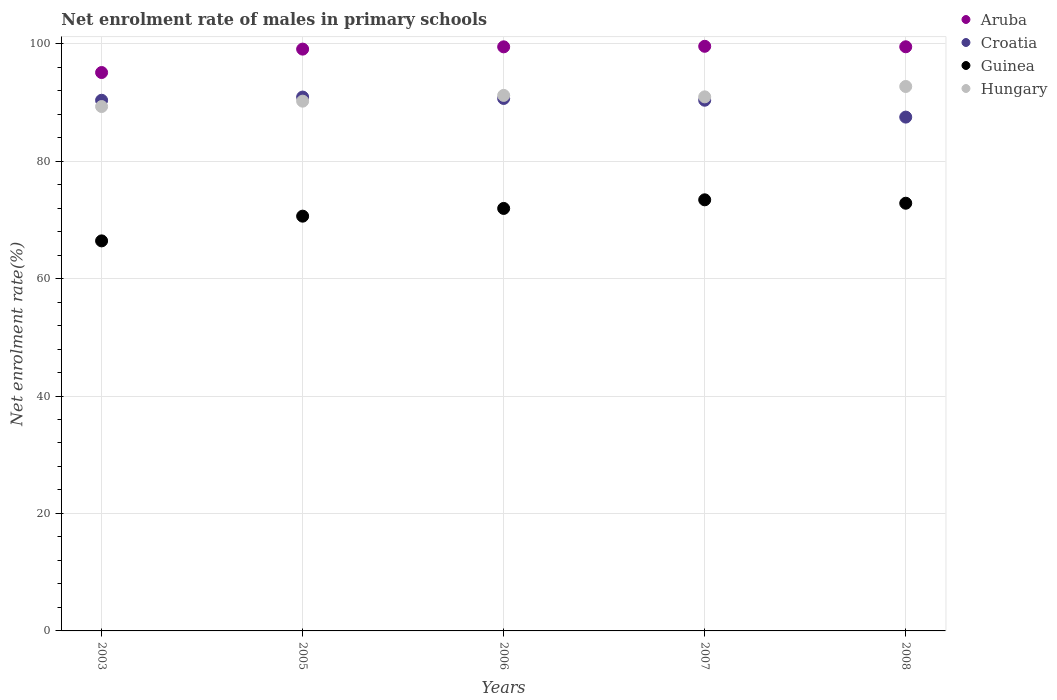Is the number of dotlines equal to the number of legend labels?
Keep it short and to the point. Yes. What is the net enrolment rate of males in primary schools in Hungary in 2008?
Ensure brevity in your answer.  92.7. Across all years, what is the maximum net enrolment rate of males in primary schools in Aruba?
Offer a very short reply. 99.55. Across all years, what is the minimum net enrolment rate of males in primary schools in Croatia?
Offer a terse response. 87.49. In which year was the net enrolment rate of males in primary schools in Guinea minimum?
Provide a succinct answer. 2003. What is the total net enrolment rate of males in primary schools in Aruba in the graph?
Make the answer very short. 492.61. What is the difference between the net enrolment rate of males in primary schools in Croatia in 2003 and that in 2005?
Provide a short and direct response. -0.55. What is the difference between the net enrolment rate of males in primary schools in Croatia in 2006 and the net enrolment rate of males in primary schools in Guinea in 2003?
Make the answer very short. 24.25. What is the average net enrolment rate of males in primary schools in Croatia per year?
Offer a terse response. 89.96. In the year 2007, what is the difference between the net enrolment rate of males in primary schools in Hungary and net enrolment rate of males in primary schools in Croatia?
Keep it short and to the point. 0.58. In how many years, is the net enrolment rate of males in primary schools in Guinea greater than 4 %?
Provide a short and direct response. 5. What is the ratio of the net enrolment rate of males in primary schools in Guinea in 2003 to that in 2006?
Make the answer very short. 0.92. Is the net enrolment rate of males in primary schools in Aruba in 2007 less than that in 2008?
Your answer should be very brief. No. What is the difference between the highest and the second highest net enrolment rate of males in primary schools in Hungary?
Your answer should be very brief. 1.52. What is the difference between the highest and the lowest net enrolment rate of males in primary schools in Guinea?
Make the answer very short. 6.99. Is the sum of the net enrolment rate of males in primary schools in Guinea in 2003 and 2007 greater than the maximum net enrolment rate of males in primary schools in Aruba across all years?
Your answer should be very brief. Yes. Is it the case that in every year, the sum of the net enrolment rate of males in primary schools in Hungary and net enrolment rate of males in primary schools in Aruba  is greater than the sum of net enrolment rate of males in primary schools in Croatia and net enrolment rate of males in primary schools in Guinea?
Give a very brief answer. Yes. Is it the case that in every year, the sum of the net enrolment rate of males in primary schools in Croatia and net enrolment rate of males in primary schools in Aruba  is greater than the net enrolment rate of males in primary schools in Guinea?
Make the answer very short. Yes. Does the net enrolment rate of males in primary schools in Hungary monotonically increase over the years?
Give a very brief answer. No. Is the net enrolment rate of males in primary schools in Croatia strictly greater than the net enrolment rate of males in primary schools in Aruba over the years?
Your answer should be very brief. No. Is the net enrolment rate of males in primary schools in Guinea strictly less than the net enrolment rate of males in primary schools in Croatia over the years?
Offer a terse response. Yes. How many years are there in the graph?
Offer a very short reply. 5. What is the difference between two consecutive major ticks on the Y-axis?
Provide a succinct answer. 20. Are the values on the major ticks of Y-axis written in scientific E-notation?
Make the answer very short. No. Does the graph contain any zero values?
Your response must be concise. No. Does the graph contain grids?
Your response must be concise. Yes. Where does the legend appear in the graph?
Keep it short and to the point. Top right. How are the legend labels stacked?
Ensure brevity in your answer.  Vertical. What is the title of the graph?
Give a very brief answer. Net enrolment rate of males in primary schools. What is the label or title of the X-axis?
Ensure brevity in your answer.  Years. What is the label or title of the Y-axis?
Keep it short and to the point. Net enrolment rate(%). What is the Net enrolment rate(%) of Aruba in 2003?
Your answer should be compact. 95.08. What is the Net enrolment rate(%) in Croatia in 2003?
Your response must be concise. 90.36. What is the Net enrolment rate(%) of Guinea in 2003?
Give a very brief answer. 66.42. What is the Net enrolment rate(%) in Hungary in 2003?
Your response must be concise. 89.29. What is the Net enrolment rate(%) in Aruba in 2005?
Keep it short and to the point. 99.07. What is the Net enrolment rate(%) of Croatia in 2005?
Give a very brief answer. 90.9. What is the Net enrolment rate(%) of Guinea in 2005?
Your answer should be compact. 70.62. What is the Net enrolment rate(%) of Hungary in 2005?
Offer a terse response. 90.21. What is the Net enrolment rate(%) of Aruba in 2006?
Keep it short and to the point. 99.46. What is the Net enrolment rate(%) in Croatia in 2006?
Make the answer very short. 90.67. What is the Net enrolment rate(%) in Guinea in 2006?
Keep it short and to the point. 71.94. What is the Net enrolment rate(%) in Hungary in 2006?
Offer a very short reply. 91.19. What is the Net enrolment rate(%) of Aruba in 2007?
Your answer should be very brief. 99.55. What is the Net enrolment rate(%) in Croatia in 2007?
Ensure brevity in your answer.  90.36. What is the Net enrolment rate(%) in Guinea in 2007?
Make the answer very short. 73.41. What is the Net enrolment rate(%) of Hungary in 2007?
Offer a very short reply. 90.94. What is the Net enrolment rate(%) of Aruba in 2008?
Offer a very short reply. 99.46. What is the Net enrolment rate(%) in Croatia in 2008?
Your answer should be compact. 87.49. What is the Net enrolment rate(%) in Guinea in 2008?
Offer a very short reply. 72.83. What is the Net enrolment rate(%) of Hungary in 2008?
Ensure brevity in your answer.  92.7. Across all years, what is the maximum Net enrolment rate(%) of Aruba?
Your answer should be compact. 99.55. Across all years, what is the maximum Net enrolment rate(%) in Croatia?
Provide a succinct answer. 90.9. Across all years, what is the maximum Net enrolment rate(%) in Guinea?
Provide a short and direct response. 73.41. Across all years, what is the maximum Net enrolment rate(%) in Hungary?
Provide a short and direct response. 92.7. Across all years, what is the minimum Net enrolment rate(%) of Aruba?
Offer a terse response. 95.08. Across all years, what is the minimum Net enrolment rate(%) of Croatia?
Provide a succinct answer. 87.49. Across all years, what is the minimum Net enrolment rate(%) of Guinea?
Offer a terse response. 66.42. Across all years, what is the minimum Net enrolment rate(%) of Hungary?
Provide a succinct answer. 89.29. What is the total Net enrolment rate(%) in Aruba in the graph?
Your answer should be very brief. 492.61. What is the total Net enrolment rate(%) in Croatia in the graph?
Your answer should be compact. 449.78. What is the total Net enrolment rate(%) of Guinea in the graph?
Offer a very short reply. 355.21. What is the total Net enrolment rate(%) in Hungary in the graph?
Your answer should be very brief. 454.32. What is the difference between the Net enrolment rate(%) of Aruba in 2003 and that in 2005?
Your answer should be compact. -3.99. What is the difference between the Net enrolment rate(%) of Croatia in 2003 and that in 2005?
Provide a succinct answer. -0.55. What is the difference between the Net enrolment rate(%) of Guinea in 2003 and that in 2005?
Offer a very short reply. -4.21. What is the difference between the Net enrolment rate(%) in Hungary in 2003 and that in 2005?
Provide a succinct answer. -0.92. What is the difference between the Net enrolment rate(%) in Aruba in 2003 and that in 2006?
Give a very brief answer. -4.37. What is the difference between the Net enrolment rate(%) in Croatia in 2003 and that in 2006?
Make the answer very short. -0.31. What is the difference between the Net enrolment rate(%) of Guinea in 2003 and that in 2006?
Offer a very short reply. -5.52. What is the difference between the Net enrolment rate(%) of Hungary in 2003 and that in 2006?
Your answer should be very brief. -1.9. What is the difference between the Net enrolment rate(%) of Aruba in 2003 and that in 2007?
Give a very brief answer. -4.46. What is the difference between the Net enrolment rate(%) of Croatia in 2003 and that in 2007?
Offer a very short reply. -0.01. What is the difference between the Net enrolment rate(%) in Guinea in 2003 and that in 2007?
Provide a succinct answer. -6.99. What is the difference between the Net enrolment rate(%) in Hungary in 2003 and that in 2007?
Offer a terse response. -1.65. What is the difference between the Net enrolment rate(%) of Aruba in 2003 and that in 2008?
Provide a short and direct response. -4.38. What is the difference between the Net enrolment rate(%) of Croatia in 2003 and that in 2008?
Offer a terse response. 2.87. What is the difference between the Net enrolment rate(%) in Guinea in 2003 and that in 2008?
Ensure brevity in your answer.  -6.41. What is the difference between the Net enrolment rate(%) in Hungary in 2003 and that in 2008?
Your answer should be very brief. -3.41. What is the difference between the Net enrolment rate(%) in Aruba in 2005 and that in 2006?
Provide a succinct answer. -0.39. What is the difference between the Net enrolment rate(%) in Croatia in 2005 and that in 2006?
Your answer should be compact. 0.24. What is the difference between the Net enrolment rate(%) in Guinea in 2005 and that in 2006?
Keep it short and to the point. -1.32. What is the difference between the Net enrolment rate(%) in Hungary in 2005 and that in 2006?
Provide a short and direct response. -0.98. What is the difference between the Net enrolment rate(%) of Aruba in 2005 and that in 2007?
Keep it short and to the point. -0.48. What is the difference between the Net enrolment rate(%) in Croatia in 2005 and that in 2007?
Provide a short and direct response. 0.54. What is the difference between the Net enrolment rate(%) of Guinea in 2005 and that in 2007?
Offer a terse response. -2.78. What is the difference between the Net enrolment rate(%) of Hungary in 2005 and that in 2007?
Ensure brevity in your answer.  -0.73. What is the difference between the Net enrolment rate(%) in Aruba in 2005 and that in 2008?
Provide a succinct answer. -0.4. What is the difference between the Net enrolment rate(%) of Croatia in 2005 and that in 2008?
Your answer should be compact. 3.41. What is the difference between the Net enrolment rate(%) of Guinea in 2005 and that in 2008?
Offer a very short reply. -2.2. What is the difference between the Net enrolment rate(%) in Hungary in 2005 and that in 2008?
Offer a very short reply. -2.5. What is the difference between the Net enrolment rate(%) in Aruba in 2006 and that in 2007?
Your answer should be compact. -0.09. What is the difference between the Net enrolment rate(%) in Croatia in 2006 and that in 2007?
Your response must be concise. 0.3. What is the difference between the Net enrolment rate(%) in Guinea in 2006 and that in 2007?
Provide a short and direct response. -1.47. What is the difference between the Net enrolment rate(%) of Hungary in 2006 and that in 2007?
Make the answer very short. 0.25. What is the difference between the Net enrolment rate(%) of Aruba in 2006 and that in 2008?
Make the answer very short. -0.01. What is the difference between the Net enrolment rate(%) in Croatia in 2006 and that in 2008?
Offer a very short reply. 3.18. What is the difference between the Net enrolment rate(%) of Guinea in 2006 and that in 2008?
Provide a short and direct response. -0.89. What is the difference between the Net enrolment rate(%) in Hungary in 2006 and that in 2008?
Your answer should be compact. -1.52. What is the difference between the Net enrolment rate(%) of Aruba in 2007 and that in 2008?
Provide a succinct answer. 0.08. What is the difference between the Net enrolment rate(%) in Croatia in 2007 and that in 2008?
Keep it short and to the point. 2.87. What is the difference between the Net enrolment rate(%) in Guinea in 2007 and that in 2008?
Your response must be concise. 0.58. What is the difference between the Net enrolment rate(%) in Hungary in 2007 and that in 2008?
Keep it short and to the point. -1.76. What is the difference between the Net enrolment rate(%) in Aruba in 2003 and the Net enrolment rate(%) in Croatia in 2005?
Keep it short and to the point. 4.18. What is the difference between the Net enrolment rate(%) of Aruba in 2003 and the Net enrolment rate(%) of Guinea in 2005?
Offer a very short reply. 24.46. What is the difference between the Net enrolment rate(%) of Aruba in 2003 and the Net enrolment rate(%) of Hungary in 2005?
Make the answer very short. 4.88. What is the difference between the Net enrolment rate(%) of Croatia in 2003 and the Net enrolment rate(%) of Guinea in 2005?
Give a very brief answer. 19.73. What is the difference between the Net enrolment rate(%) of Croatia in 2003 and the Net enrolment rate(%) of Hungary in 2005?
Offer a terse response. 0.15. What is the difference between the Net enrolment rate(%) in Guinea in 2003 and the Net enrolment rate(%) in Hungary in 2005?
Offer a terse response. -23.79. What is the difference between the Net enrolment rate(%) in Aruba in 2003 and the Net enrolment rate(%) in Croatia in 2006?
Offer a very short reply. 4.42. What is the difference between the Net enrolment rate(%) in Aruba in 2003 and the Net enrolment rate(%) in Guinea in 2006?
Provide a succinct answer. 23.14. What is the difference between the Net enrolment rate(%) in Aruba in 2003 and the Net enrolment rate(%) in Hungary in 2006?
Ensure brevity in your answer.  3.9. What is the difference between the Net enrolment rate(%) in Croatia in 2003 and the Net enrolment rate(%) in Guinea in 2006?
Make the answer very short. 18.42. What is the difference between the Net enrolment rate(%) in Croatia in 2003 and the Net enrolment rate(%) in Hungary in 2006?
Offer a terse response. -0.83. What is the difference between the Net enrolment rate(%) of Guinea in 2003 and the Net enrolment rate(%) of Hungary in 2006?
Offer a terse response. -24.77. What is the difference between the Net enrolment rate(%) of Aruba in 2003 and the Net enrolment rate(%) of Croatia in 2007?
Your answer should be very brief. 4.72. What is the difference between the Net enrolment rate(%) in Aruba in 2003 and the Net enrolment rate(%) in Guinea in 2007?
Your answer should be very brief. 21.68. What is the difference between the Net enrolment rate(%) of Aruba in 2003 and the Net enrolment rate(%) of Hungary in 2007?
Provide a short and direct response. 4.14. What is the difference between the Net enrolment rate(%) of Croatia in 2003 and the Net enrolment rate(%) of Guinea in 2007?
Keep it short and to the point. 16.95. What is the difference between the Net enrolment rate(%) in Croatia in 2003 and the Net enrolment rate(%) in Hungary in 2007?
Offer a very short reply. -0.58. What is the difference between the Net enrolment rate(%) of Guinea in 2003 and the Net enrolment rate(%) of Hungary in 2007?
Your response must be concise. -24.52. What is the difference between the Net enrolment rate(%) of Aruba in 2003 and the Net enrolment rate(%) of Croatia in 2008?
Your answer should be compact. 7.59. What is the difference between the Net enrolment rate(%) of Aruba in 2003 and the Net enrolment rate(%) of Guinea in 2008?
Make the answer very short. 22.26. What is the difference between the Net enrolment rate(%) of Aruba in 2003 and the Net enrolment rate(%) of Hungary in 2008?
Your response must be concise. 2.38. What is the difference between the Net enrolment rate(%) of Croatia in 2003 and the Net enrolment rate(%) of Guinea in 2008?
Offer a terse response. 17.53. What is the difference between the Net enrolment rate(%) of Croatia in 2003 and the Net enrolment rate(%) of Hungary in 2008?
Provide a succinct answer. -2.35. What is the difference between the Net enrolment rate(%) in Guinea in 2003 and the Net enrolment rate(%) in Hungary in 2008?
Your response must be concise. -26.29. What is the difference between the Net enrolment rate(%) of Aruba in 2005 and the Net enrolment rate(%) of Croatia in 2006?
Make the answer very short. 8.4. What is the difference between the Net enrolment rate(%) of Aruba in 2005 and the Net enrolment rate(%) of Guinea in 2006?
Provide a short and direct response. 27.13. What is the difference between the Net enrolment rate(%) in Aruba in 2005 and the Net enrolment rate(%) in Hungary in 2006?
Provide a short and direct response. 7.88. What is the difference between the Net enrolment rate(%) of Croatia in 2005 and the Net enrolment rate(%) of Guinea in 2006?
Keep it short and to the point. 18.96. What is the difference between the Net enrolment rate(%) in Croatia in 2005 and the Net enrolment rate(%) in Hungary in 2006?
Make the answer very short. -0.28. What is the difference between the Net enrolment rate(%) of Guinea in 2005 and the Net enrolment rate(%) of Hungary in 2006?
Keep it short and to the point. -20.56. What is the difference between the Net enrolment rate(%) of Aruba in 2005 and the Net enrolment rate(%) of Croatia in 2007?
Make the answer very short. 8.7. What is the difference between the Net enrolment rate(%) in Aruba in 2005 and the Net enrolment rate(%) in Guinea in 2007?
Make the answer very short. 25.66. What is the difference between the Net enrolment rate(%) in Aruba in 2005 and the Net enrolment rate(%) in Hungary in 2007?
Give a very brief answer. 8.13. What is the difference between the Net enrolment rate(%) in Croatia in 2005 and the Net enrolment rate(%) in Guinea in 2007?
Offer a very short reply. 17.5. What is the difference between the Net enrolment rate(%) of Croatia in 2005 and the Net enrolment rate(%) of Hungary in 2007?
Your response must be concise. -0.04. What is the difference between the Net enrolment rate(%) of Guinea in 2005 and the Net enrolment rate(%) of Hungary in 2007?
Your response must be concise. -20.32. What is the difference between the Net enrolment rate(%) of Aruba in 2005 and the Net enrolment rate(%) of Croatia in 2008?
Your response must be concise. 11.58. What is the difference between the Net enrolment rate(%) of Aruba in 2005 and the Net enrolment rate(%) of Guinea in 2008?
Your response must be concise. 26.24. What is the difference between the Net enrolment rate(%) of Aruba in 2005 and the Net enrolment rate(%) of Hungary in 2008?
Provide a short and direct response. 6.36. What is the difference between the Net enrolment rate(%) of Croatia in 2005 and the Net enrolment rate(%) of Guinea in 2008?
Provide a succinct answer. 18.08. What is the difference between the Net enrolment rate(%) in Croatia in 2005 and the Net enrolment rate(%) in Hungary in 2008?
Provide a short and direct response. -1.8. What is the difference between the Net enrolment rate(%) of Guinea in 2005 and the Net enrolment rate(%) of Hungary in 2008?
Your response must be concise. -22.08. What is the difference between the Net enrolment rate(%) of Aruba in 2006 and the Net enrolment rate(%) of Croatia in 2007?
Your response must be concise. 9.09. What is the difference between the Net enrolment rate(%) of Aruba in 2006 and the Net enrolment rate(%) of Guinea in 2007?
Ensure brevity in your answer.  26.05. What is the difference between the Net enrolment rate(%) in Aruba in 2006 and the Net enrolment rate(%) in Hungary in 2007?
Provide a short and direct response. 8.52. What is the difference between the Net enrolment rate(%) of Croatia in 2006 and the Net enrolment rate(%) of Guinea in 2007?
Make the answer very short. 17.26. What is the difference between the Net enrolment rate(%) in Croatia in 2006 and the Net enrolment rate(%) in Hungary in 2007?
Your response must be concise. -0.27. What is the difference between the Net enrolment rate(%) of Guinea in 2006 and the Net enrolment rate(%) of Hungary in 2007?
Provide a succinct answer. -19. What is the difference between the Net enrolment rate(%) in Aruba in 2006 and the Net enrolment rate(%) in Croatia in 2008?
Offer a very short reply. 11.97. What is the difference between the Net enrolment rate(%) of Aruba in 2006 and the Net enrolment rate(%) of Guinea in 2008?
Offer a very short reply. 26.63. What is the difference between the Net enrolment rate(%) of Aruba in 2006 and the Net enrolment rate(%) of Hungary in 2008?
Provide a succinct answer. 6.75. What is the difference between the Net enrolment rate(%) in Croatia in 2006 and the Net enrolment rate(%) in Guinea in 2008?
Provide a succinct answer. 17.84. What is the difference between the Net enrolment rate(%) in Croatia in 2006 and the Net enrolment rate(%) in Hungary in 2008?
Give a very brief answer. -2.04. What is the difference between the Net enrolment rate(%) in Guinea in 2006 and the Net enrolment rate(%) in Hungary in 2008?
Make the answer very short. -20.76. What is the difference between the Net enrolment rate(%) of Aruba in 2007 and the Net enrolment rate(%) of Croatia in 2008?
Make the answer very short. 12.06. What is the difference between the Net enrolment rate(%) of Aruba in 2007 and the Net enrolment rate(%) of Guinea in 2008?
Give a very brief answer. 26.72. What is the difference between the Net enrolment rate(%) in Aruba in 2007 and the Net enrolment rate(%) in Hungary in 2008?
Make the answer very short. 6.84. What is the difference between the Net enrolment rate(%) in Croatia in 2007 and the Net enrolment rate(%) in Guinea in 2008?
Make the answer very short. 17.54. What is the difference between the Net enrolment rate(%) of Croatia in 2007 and the Net enrolment rate(%) of Hungary in 2008?
Your answer should be compact. -2.34. What is the difference between the Net enrolment rate(%) in Guinea in 2007 and the Net enrolment rate(%) in Hungary in 2008?
Give a very brief answer. -19.3. What is the average Net enrolment rate(%) in Aruba per year?
Provide a short and direct response. 98.52. What is the average Net enrolment rate(%) of Croatia per year?
Your answer should be very brief. 89.96. What is the average Net enrolment rate(%) in Guinea per year?
Give a very brief answer. 71.04. What is the average Net enrolment rate(%) in Hungary per year?
Provide a short and direct response. 90.86. In the year 2003, what is the difference between the Net enrolment rate(%) in Aruba and Net enrolment rate(%) in Croatia?
Make the answer very short. 4.73. In the year 2003, what is the difference between the Net enrolment rate(%) in Aruba and Net enrolment rate(%) in Guinea?
Provide a short and direct response. 28.67. In the year 2003, what is the difference between the Net enrolment rate(%) in Aruba and Net enrolment rate(%) in Hungary?
Keep it short and to the point. 5.79. In the year 2003, what is the difference between the Net enrolment rate(%) in Croatia and Net enrolment rate(%) in Guinea?
Offer a terse response. 23.94. In the year 2003, what is the difference between the Net enrolment rate(%) of Croatia and Net enrolment rate(%) of Hungary?
Ensure brevity in your answer.  1.07. In the year 2003, what is the difference between the Net enrolment rate(%) of Guinea and Net enrolment rate(%) of Hungary?
Ensure brevity in your answer.  -22.88. In the year 2005, what is the difference between the Net enrolment rate(%) in Aruba and Net enrolment rate(%) in Croatia?
Offer a very short reply. 8.16. In the year 2005, what is the difference between the Net enrolment rate(%) of Aruba and Net enrolment rate(%) of Guinea?
Make the answer very short. 28.44. In the year 2005, what is the difference between the Net enrolment rate(%) of Aruba and Net enrolment rate(%) of Hungary?
Provide a succinct answer. 8.86. In the year 2005, what is the difference between the Net enrolment rate(%) in Croatia and Net enrolment rate(%) in Guinea?
Provide a short and direct response. 20.28. In the year 2005, what is the difference between the Net enrolment rate(%) in Croatia and Net enrolment rate(%) in Hungary?
Offer a terse response. 0.7. In the year 2005, what is the difference between the Net enrolment rate(%) in Guinea and Net enrolment rate(%) in Hungary?
Your response must be concise. -19.58. In the year 2006, what is the difference between the Net enrolment rate(%) in Aruba and Net enrolment rate(%) in Croatia?
Your response must be concise. 8.79. In the year 2006, what is the difference between the Net enrolment rate(%) of Aruba and Net enrolment rate(%) of Guinea?
Your answer should be compact. 27.52. In the year 2006, what is the difference between the Net enrolment rate(%) in Aruba and Net enrolment rate(%) in Hungary?
Offer a terse response. 8.27. In the year 2006, what is the difference between the Net enrolment rate(%) of Croatia and Net enrolment rate(%) of Guinea?
Your answer should be compact. 18.73. In the year 2006, what is the difference between the Net enrolment rate(%) in Croatia and Net enrolment rate(%) in Hungary?
Offer a very short reply. -0.52. In the year 2006, what is the difference between the Net enrolment rate(%) in Guinea and Net enrolment rate(%) in Hungary?
Offer a terse response. -19.25. In the year 2007, what is the difference between the Net enrolment rate(%) of Aruba and Net enrolment rate(%) of Croatia?
Offer a terse response. 9.18. In the year 2007, what is the difference between the Net enrolment rate(%) of Aruba and Net enrolment rate(%) of Guinea?
Provide a short and direct response. 26.14. In the year 2007, what is the difference between the Net enrolment rate(%) of Aruba and Net enrolment rate(%) of Hungary?
Offer a terse response. 8.61. In the year 2007, what is the difference between the Net enrolment rate(%) of Croatia and Net enrolment rate(%) of Guinea?
Keep it short and to the point. 16.96. In the year 2007, what is the difference between the Net enrolment rate(%) of Croatia and Net enrolment rate(%) of Hungary?
Your response must be concise. -0.58. In the year 2007, what is the difference between the Net enrolment rate(%) of Guinea and Net enrolment rate(%) of Hungary?
Provide a short and direct response. -17.53. In the year 2008, what is the difference between the Net enrolment rate(%) of Aruba and Net enrolment rate(%) of Croatia?
Ensure brevity in your answer.  11.97. In the year 2008, what is the difference between the Net enrolment rate(%) in Aruba and Net enrolment rate(%) in Guinea?
Provide a succinct answer. 26.64. In the year 2008, what is the difference between the Net enrolment rate(%) of Aruba and Net enrolment rate(%) of Hungary?
Give a very brief answer. 6.76. In the year 2008, what is the difference between the Net enrolment rate(%) of Croatia and Net enrolment rate(%) of Guinea?
Provide a succinct answer. 14.66. In the year 2008, what is the difference between the Net enrolment rate(%) of Croatia and Net enrolment rate(%) of Hungary?
Keep it short and to the point. -5.21. In the year 2008, what is the difference between the Net enrolment rate(%) in Guinea and Net enrolment rate(%) in Hungary?
Ensure brevity in your answer.  -19.88. What is the ratio of the Net enrolment rate(%) in Aruba in 2003 to that in 2005?
Give a very brief answer. 0.96. What is the ratio of the Net enrolment rate(%) of Croatia in 2003 to that in 2005?
Give a very brief answer. 0.99. What is the ratio of the Net enrolment rate(%) of Guinea in 2003 to that in 2005?
Make the answer very short. 0.94. What is the ratio of the Net enrolment rate(%) in Aruba in 2003 to that in 2006?
Ensure brevity in your answer.  0.96. What is the ratio of the Net enrolment rate(%) of Croatia in 2003 to that in 2006?
Keep it short and to the point. 1. What is the ratio of the Net enrolment rate(%) in Guinea in 2003 to that in 2006?
Make the answer very short. 0.92. What is the ratio of the Net enrolment rate(%) of Hungary in 2003 to that in 2006?
Provide a short and direct response. 0.98. What is the ratio of the Net enrolment rate(%) of Aruba in 2003 to that in 2007?
Your answer should be very brief. 0.96. What is the ratio of the Net enrolment rate(%) in Croatia in 2003 to that in 2007?
Give a very brief answer. 1. What is the ratio of the Net enrolment rate(%) of Guinea in 2003 to that in 2007?
Provide a succinct answer. 0.9. What is the ratio of the Net enrolment rate(%) of Hungary in 2003 to that in 2007?
Provide a short and direct response. 0.98. What is the ratio of the Net enrolment rate(%) of Aruba in 2003 to that in 2008?
Your response must be concise. 0.96. What is the ratio of the Net enrolment rate(%) of Croatia in 2003 to that in 2008?
Give a very brief answer. 1.03. What is the ratio of the Net enrolment rate(%) in Guinea in 2003 to that in 2008?
Keep it short and to the point. 0.91. What is the ratio of the Net enrolment rate(%) in Hungary in 2003 to that in 2008?
Your answer should be very brief. 0.96. What is the ratio of the Net enrolment rate(%) of Aruba in 2005 to that in 2006?
Make the answer very short. 1. What is the ratio of the Net enrolment rate(%) of Croatia in 2005 to that in 2006?
Give a very brief answer. 1. What is the ratio of the Net enrolment rate(%) in Guinea in 2005 to that in 2006?
Your answer should be very brief. 0.98. What is the ratio of the Net enrolment rate(%) in Hungary in 2005 to that in 2006?
Your answer should be very brief. 0.99. What is the ratio of the Net enrolment rate(%) in Guinea in 2005 to that in 2007?
Your answer should be very brief. 0.96. What is the ratio of the Net enrolment rate(%) of Hungary in 2005 to that in 2007?
Your response must be concise. 0.99. What is the ratio of the Net enrolment rate(%) of Aruba in 2005 to that in 2008?
Make the answer very short. 1. What is the ratio of the Net enrolment rate(%) of Croatia in 2005 to that in 2008?
Keep it short and to the point. 1.04. What is the ratio of the Net enrolment rate(%) in Guinea in 2005 to that in 2008?
Give a very brief answer. 0.97. What is the ratio of the Net enrolment rate(%) of Hungary in 2005 to that in 2008?
Offer a terse response. 0.97. What is the ratio of the Net enrolment rate(%) in Aruba in 2006 to that in 2007?
Make the answer very short. 1. What is the ratio of the Net enrolment rate(%) of Guinea in 2006 to that in 2007?
Provide a succinct answer. 0.98. What is the ratio of the Net enrolment rate(%) in Hungary in 2006 to that in 2007?
Your answer should be compact. 1. What is the ratio of the Net enrolment rate(%) in Aruba in 2006 to that in 2008?
Make the answer very short. 1. What is the ratio of the Net enrolment rate(%) in Croatia in 2006 to that in 2008?
Ensure brevity in your answer.  1.04. What is the ratio of the Net enrolment rate(%) of Guinea in 2006 to that in 2008?
Offer a terse response. 0.99. What is the ratio of the Net enrolment rate(%) of Hungary in 2006 to that in 2008?
Offer a very short reply. 0.98. What is the ratio of the Net enrolment rate(%) in Croatia in 2007 to that in 2008?
Your answer should be compact. 1.03. What is the difference between the highest and the second highest Net enrolment rate(%) of Aruba?
Offer a very short reply. 0.08. What is the difference between the highest and the second highest Net enrolment rate(%) of Croatia?
Keep it short and to the point. 0.24. What is the difference between the highest and the second highest Net enrolment rate(%) in Guinea?
Your response must be concise. 0.58. What is the difference between the highest and the second highest Net enrolment rate(%) of Hungary?
Your answer should be very brief. 1.52. What is the difference between the highest and the lowest Net enrolment rate(%) in Aruba?
Provide a succinct answer. 4.46. What is the difference between the highest and the lowest Net enrolment rate(%) of Croatia?
Offer a terse response. 3.41. What is the difference between the highest and the lowest Net enrolment rate(%) in Guinea?
Keep it short and to the point. 6.99. What is the difference between the highest and the lowest Net enrolment rate(%) in Hungary?
Give a very brief answer. 3.41. 